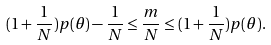Convert formula to latex. <formula><loc_0><loc_0><loc_500><loc_500>( 1 + \frac { 1 } { N } ) p ( \theta ) - \frac { 1 } { N } \leq \frac { m } { N } \leq ( 1 + \frac { 1 } { N } ) p ( \theta ) .</formula> 